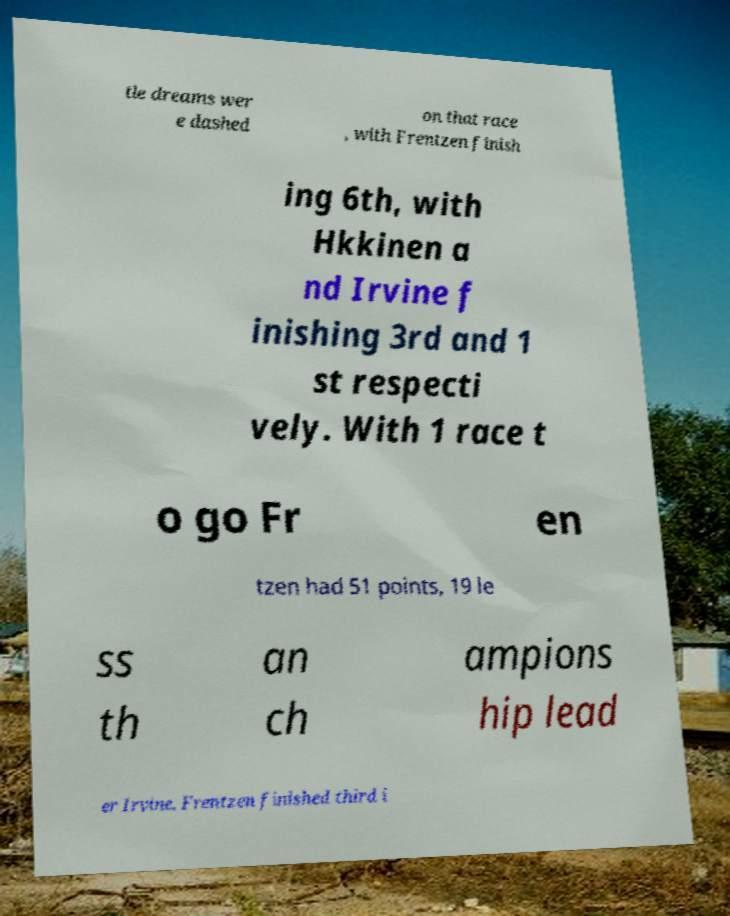Could you assist in decoding the text presented in this image and type it out clearly? tle dreams wer e dashed on that race , with Frentzen finish ing 6th, with Hkkinen a nd Irvine f inishing 3rd and 1 st respecti vely. With 1 race t o go Fr en tzen had 51 points, 19 le ss th an ch ampions hip lead er Irvine. Frentzen finished third i 